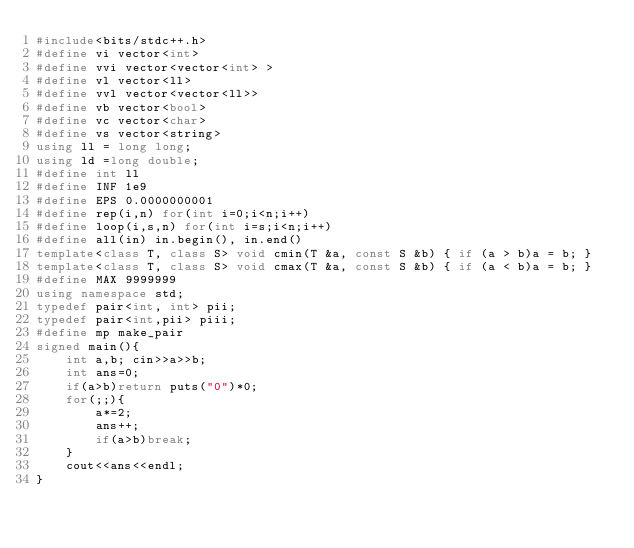<code> <loc_0><loc_0><loc_500><loc_500><_C++_>#include<bits/stdc++.h>
#define vi vector<int>
#define vvi vector<vector<int> >
#define vl vector<ll>
#define vvl vector<vector<ll>>
#define vb vector<bool>
#define vc vector<char>
#define vs vector<string>
using ll = long long;
using ld =long double;
#define int ll
#define INF 1e9
#define EPS 0.0000000001
#define rep(i,n) for(int i=0;i<n;i++)
#define loop(i,s,n) for(int i=s;i<n;i++)
#define all(in) in.begin(), in.end()
template<class T, class S> void cmin(T &a, const S &b) { if (a > b)a = b; }
template<class T, class S> void cmax(T &a, const S &b) { if (a < b)a = b; }
#define MAX 9999999
using namespace std;
typedef pair<int, int> pii;
typedef pair<int,pii> piii;
#define mp make_pair
signed main(){
    int a,b; cin>>a>>b;
    int ans=0;
    if(a>b)return puts("0")*0;
    for(;;){
        a*=2;
        ans++;
        if(a>b)break;
    }
    cout<<ans<<endl;
}
</code> 